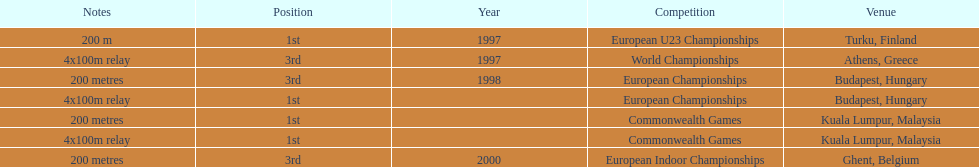In what year between 1997 and 2000 did julian golding, the sprinter representing the united kingdom and england finish first in both the 4 x 100 m relay and the 200 metres race? 1998. 